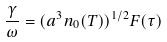Convert formula to latex. <formula><loc_0><loc_0><loc_500><loc_500>\frac { \gamma } { \omega } = ( a ^ { 3 } n _ { 0 } ( T ) ) ^ { 1 / 2 } F ( \tau )</formula> 